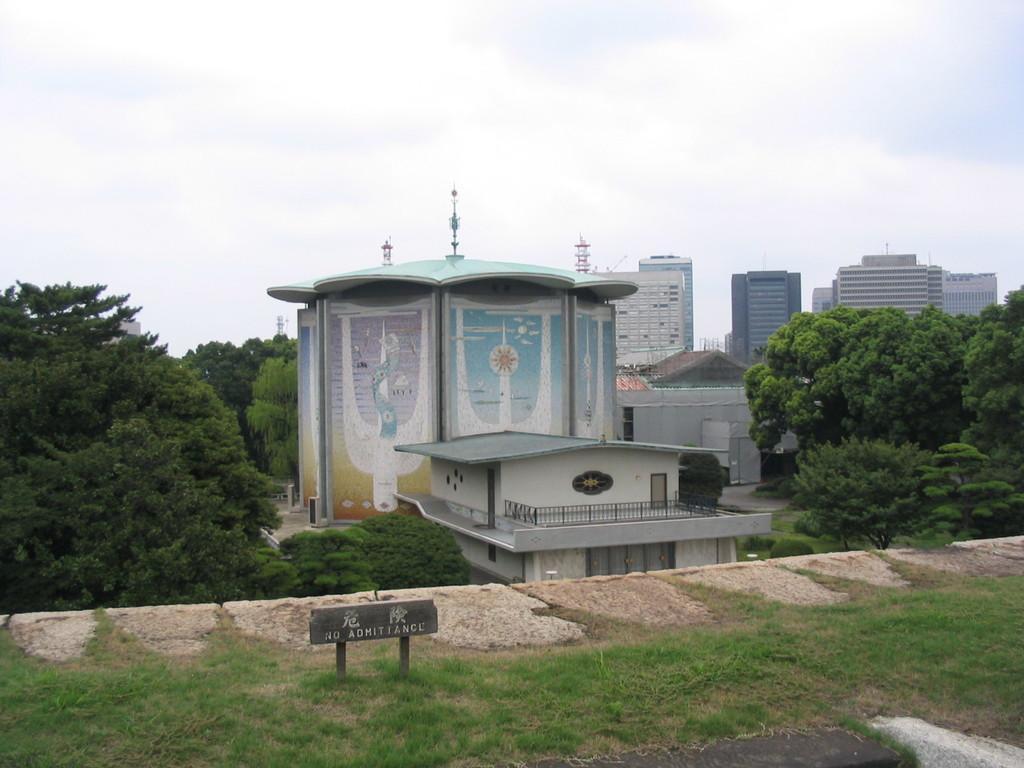Please provide a concise description of this image. At the bottom of the image on the ground there is grass and also there is a board and rocks. Behind that there are buildings and trees. At the top of the image there is sky. 